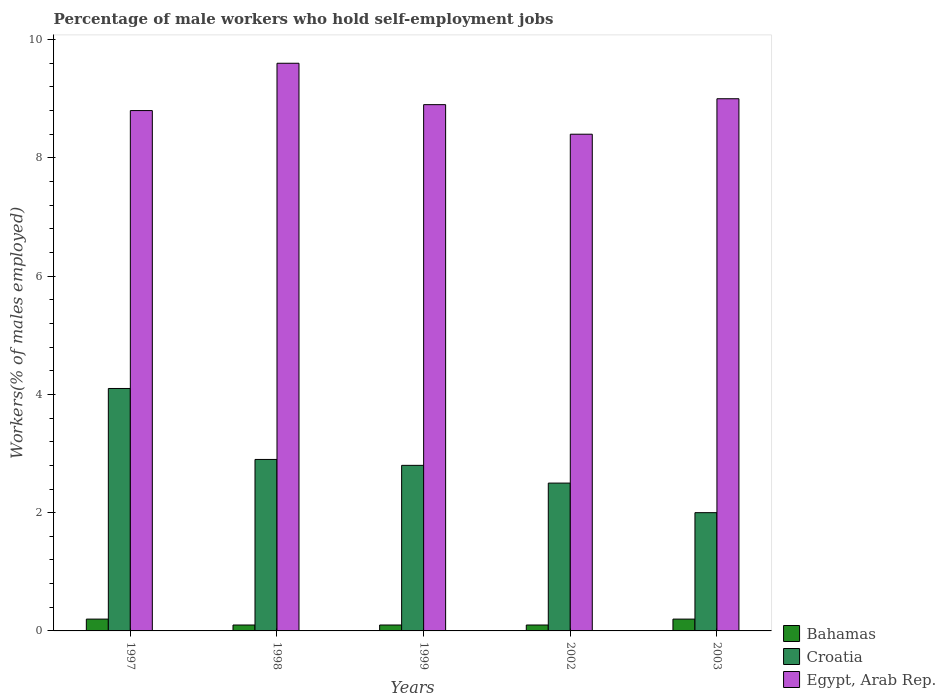How many different coloured bars are there?
Your response must be concise. 3. Are the number of bars on each tick of the X-axis equal?
Your answer should be compact. Yes. How many bars are there on the 1st tick from the right?
Ensure brevity in your answer.  3. What is the label of the 3rd group of bars from the left?
Offer a terse response. 1999. In how many cases, is the number of bars for a given year not equal to the number of legend labels?
Your response must be concise. 0. What is the percentage of self-employed male workers in Egypt, Arab Rep. in 1998?
Make the answer very short. 9.6. Across all years, what is the maximum percentage of self-employed male workers in Egypt, Arab Rep.?
Ensure brevity in your answer.  9.6. Across all years, what is the minimum percentage of self-employed male workers in Bahamas?
Give a very brief answer. 0.1. What is the total percentage of self-employed male workers in Croatia in the graph?
Make the answer very short. 14.3. What is the difference between the percentage of self-employed male workers in Bahamas in 1999 and that in 2003?
Provide a succinct answer. -0.1. What is the difference between the percentage of self-employed male workers in Egypt, Arab Rep. in 2003 and the percentage of self-employed male workers in Croatia in 1999?
Make the answer very short. 6.2. What is the average percentage of self-employed male workers in Bahamas per year?
Your response must be concise. 0.14. In the year 1999, what is the difference between the percentage of self-employed male workers in Bahamas and percentage of self-employed male workers in Croatia?
Your answer should be very brief. -2.7. What is the difference between the highest and the second highest percentage of self-employed male workers in Croatia?
Your answer should be very brief. 1.2. What is the difference between the highest and the lowest percentage of self-employed male workers in Croatia?
Give a very brief answer. 2.1. In how many years, is the percentage of self-employed male workers in Croatia greater than the average percentage of self-employed male workers in Croatia taken over all years?
Offer a terse response. 2. Is the sum of the percentage of self-employed male workers in Bahamas in 1997 and 1999 greater than the maximum percentage of self-employed male workers in Croatia across all years?
Your response must be concise. No. What does the 2nd bar from the left in 1997 represents?
Your answer should be compact. Croatia. What does the 3rd bar from the right in 1999 represents?
Offer a terse response. Bahamas. How many bars are there?
Offer a very short reply. 15. How many years are there in the graph?
Keep it short and to the point. 5. Are the values on the major ticks of Y-axis written in scientific E-notation?
Offer a terse response. No. Does the graph contain any zero values?
Provide a succinct answer. No. How many legend labels are there?
Give a very brief answer. 3. How are the legend labels stacked?
Your answer should be compact. Vertical. What is the title of the graph?
Offer a terse response. Percentage of male workers who hold self-employment jobs. What is the label or title of the X-axis?
Keep it short and to the point. Years. What is the label or title of the Y-axis?
Your answer should be compact. Workers(% of males employed). What is the Workers(% of males employed) in Bahamas in 1997?
Provide a succinct answer. 0.2. What is the Workers(% of males employed) in Croatia in 1997?
Your response must be concise. 4.1. What is the Workers(% of males employed) of Egypt, Arab Rep. in 1997?
Your answer should be compact. 8.8. What is the Workers(% of males employed) in Bahamas in 1998?
Your answer should be very brief. 0.1. What is the Workers(% of males employed) of Croatia in 1998?
Provide a succinct answer. 2.9. What is the Workers(% of males employed) in Egypt, Arab Rep. in 1998?
Provide a succinct answer. 9.6. What is the Workers(% of males employed) of Bahamas in 1999?
Keep it short and to the point. 0.1. What is the Workers(% of males employed) in Croatia in 1999?
Ensure brevity in your answer.  2.8. What is the Workers(% of males employed) of Egypt, Arab Rep. in 1999?
Keep it short and to the point. 8.9. What is the Workers(% of males employed) in Bahamas in 2002?
Provide a succinct answer. 0.1. What is the Workers(% of males employed) of Egypt, Arab Rep. in 2002?
Give a very brief answer. 8.4. What is the Workers(% of males employed) of Bahamas in 2003?
Ensure brevity in your answer.  0.2. What is the Workers(% of males employed) in Croatia in 2003?
Make the answer very short. 2. What is the Workers(% of males employed) in Egypt, Arab Rep. in 2003?
Give a very brief answer. 9. Across all years, what is the maximum Workers(% of males employed) of Bahamas?
Your answer should be compact. 0.2. Across all years, what is the maximum Workers(% of males employed) in Croatia?
Give a very brief answer. 4.1. Across all years, what is the maximum Workers(% of males employed) in Egypt, Arab Rep.?
Ensure brevity in your answer.  9.6. Across all years, what is the minimum Workers(% of males employed) of Bahamas?
Provide a succinct answer. 0.1. Across all years, what is the minimum Workers(% of males employed) in Egypt, Arab Rep.?
Make the answer very short. 8.4. What is the total Workers(% of males employed) in Bahamas in the graph?
Your answer should be very brief. 0.7. What is the total Workers(% of males employed) of Egypt, Arab Rep. in the graph?
Your answer should be very brief. 44.7. What is the difference between the Workers(% of males employed) in Egypt, Arab Rep. in 1997 and that in 1998?
Your response must be concise. -0.8. What is the difference between the Workers(% of males employed) of Bahamas in 1997 and that in 1999?
Your answer should be compact. 0.1. What is the difference between the Workers(% of males employed) of Egypt, Arab Rep. in 1997 and that in 1999?
Provide a succinct answer. -0.1. What is the difference between the Workers(% of males employed) of Bahamas in 1997 and that in 2002?
Your answer should be compact. 0.1. What is the difference between the Workers(% of males employed) of Croatia in 1997 and that in 2002?
Your answer should be compact. 1.6. What is the difference between the Workers(% of males employed) of Croatia in 1997 and that in 2003?
Ensure brevity in your answer.  2.1. What is the difference between the Workers(% of males employed) of Croatia in 1998 and that in 1999?
Your response must be concise. 0.1. What is the difference between the Workers(% of males employed) of Egypt, Arab Rep. in 1998 and that in 1999?
Offer a very short reply. 0.7. What is the difference between the Workers(% of males employed) in Croatia in 1998 and that in 2002?
Ensure brevity in your answer.  0.4. What is the difference between the Workers(% of males employed) in Egypt, Arab Rep. in 1998 and that in 2002?
Your answer should be very brief. 1.2. What is the difference between the Workers(% of males employed) of Croatia in 1998 and that in 2003?
Offer a terse response. 0.9. What is the difference between the Workers(% of males employed) of Egypt, Arab Rep. in 1998 and that in 2003?
Your response must be concise. 0.6. What is the difference between the Workers(% of males employed) in Bahamas in 1999 and that in 2002?
Make the answer very short. 0. What is the difference between the Workers(% of males employed) in Croatia in 1999 and that in 2002?
Make the answer very short. 0.3. What is the difference between the Workers(% of males employed) of Egypt, Arab Rep. in 1999 and that in 2002?
Offer a terse response. 0.5. What is the difference between the Workers(% of males employed) in Bahamas in 1999 and that in 2003?
Provide a short and direct response. -0.1. What is the difference between the Workers(% of males employed) of Egypt, Arab Rep. in 1999 and that in 2003?
Provide a succinct answer. -0.1. What is the difference between the Workers(% of males employed) of Croatia in 2002 and that in 2003?
Give a very brief answer. 0.5. What is the difference between the Workers(% of males employed) of Egypt, Arab Rep. in 2002 and that in 2003?
Ensure brevity in your answer.  -0.6. What is the difference between the Workers(% of males employed) in Bahamas in 1997 and the Workers(% of males employed) in Egypt, Arab Rep. in 1998?
Make the answer very short. -9.4. What is the difference between the Workers(% of males employed) in Croatia in 1997 and the Workers(% of males employed) in Egypt, Arab Rep. in 1998?
Ensure brevity in your answer.  -5.5. What is the difference between the Workers(% of males employed) in Bahamas in 1997 and the Workers(% of males employed) in Croatia in 1999?
Keep it short and to the point. -2.6. What is the difference between the Workers(% of males employed) in Croatia in 1997 and the Workers(% of males employed) in Egypt, Arab Rep. in 1999?
Your answer should be compact. -4.8. What is the difference between the Workers(% of males employed) of Bahamas in 1997 and the Workers(% of males employed) of Croatia in 2002?
Your response must be concise. -2.3. What is the difference between the Workers(% of males employed) in Bahamas in 1997 and the Workers(% of males employed) in Egypt, Arab Rep. in 2003?
Provide a succinct answer. -8.8. What is the difference between the Workers(% of males employed) of Croatia in 1998 and the Workers(% of males employed) of Egypt, Arab Rep. in 1999?
Offer a very short reply. -6. What is the difference between the Workers(% of males employed) in Bahamas in 1998 and the Workers(% of males employed) in Egypt, Arab Rep. in 2002?
Provide a succinct answer. -8.3. What is the difference between the Workers(% of males employed) in Croatia in 1998 and the Workers(% of males employed) in Egypt, Arab Rep. in 2002?
Offer a terse response. -5.5. What is the difference between the Workers(% of males employed) of Bahamas in 1998 and the Workers(% of males employed) of Egypt, Arab Rep. in 2003?
Provide a succinct answer. -8.9. What is the difference between the Workers(% of males employed) of Bahamas in 1999 and the Workers(% of males employed) of Croatia in 2002?
Make the answer very short. -2.4. What is the difference between the Workers(% of males employed) of Croatia in 1999 and the Workers(% of males employed) of Egypt, Arab Rep. in 2002?
Offer a terse response. -5.6. What is the difference between the Workers(% of males employed) of Bahamas in 1999 and the Workers(% of males employed) of Egypt, Arab Rep. in 2003?
Your answer should be compact. -8.9. What is the difference between the Workers(% of males employed) of Croatia in 1999 and the Workers(% of males employed) of Egypt, Arab Rep. in 2003?
Keep it short and to the point. -6.2. What is the difference between the Workers(% of males employed) in Bahamas in 2002 and the Workers(% of males employed) in Egypt, Arab Rep. in 2003?
Provide a short and direct response. -8.9. What is the difference between the Workers(% of males employed) in Croatia in 2002 and the Workers(% of males employed) in Egypt, Arab Rep. in 2003?
Keep it short and to the point. -6.5. What is the average Workers(% of males employed) in Bahamas per year?
Your answer should be very brief. 0.14. What is the average Workers(% of males employed) of Croatia per year?
Make the answer very short. 2.86. What is the average Workers(% of males employed) of Egypt, Arab Rep. per year?
Provide a succinct answer. 8.94. In the year 1997, what is the difference between the Workers(% of males employed) of Bahamas and Workers(% of males employed) of Croatia?
Your answer should be very brief. -3.9. In the year 1997, what is the difference between the Workers(% of males employed) in Bahamas and Workers(% of males employed) in Egypt, Arab Rep.?
Ensure brevity in your answer.  -8.6. In the year 1998, what is the difference between the Workers(% of males employed) in Bahamas and Workers(% of males employed) in Egypt, Arab Rep.?
Your response must be concise. -9.5. In the year 1998, what is the difference between the Workers(% of males employed) of Croatia and Workers(% of males employed) of Egypt, Arab Rep.?
Give a very brief answer. -6.7. In the year 1999, what is the difference between the Workers(% of males employed) of Croatia and Workers(% of males employed) of Egypt, Arab Rep.?
Make the answer very short. -6.1. In the year 2002, what is the difference between the Workers(% of males employed) in Bahamas and Workers(% of males employed) in Egypt, Arab Rep.?
Ensure brevity in your answer.  -8.3. In the year 2002, what is the difference between the Workers(% of males employed) in Croatia and Workers(% of males employed) in Egypt, Arab Rep.?
Provide a short and direct response. -5.9. In the year 2003, what is the difference between the Workers(% of males employed) in Bahamas and Workers(% of males employed) in Egypt, Arab Rep.?
Make the answer very short. -8.8. In the year 2003, what is the difference between the Workers(% of males employed) of Croatia and Workers(% of males employed) of Egypt, Arab Rep.?
Make the answer very short. -7. What is the ratio of the Workers(% of males employed) of Croatia in 1997 to that in 1998?
Your response must be concise. 1.41. What is the ratio of the Workers(% of males employed) in Egypt, Arab Rep. in 1997 to that in 1998?
Keep it short and to the point. 0.92. What is the ratio of the Workers(% of males employed) of Croatia in 1997 to that in 1999?
Offer a very short reply. 1.46. What is the ratio of the Workers(% of males employed) of Bahamas in 1997 to that in 2002?
Give a very brief answer. 2. What is the ratio of the Workers(% of males employed) in Croatia in 1997 to that in 2002?
Offer a very short reply. 1.64. What is the ratio of the Workers(% of males employed) in Egypt, Arab Rep. in 1997 to that in 2002?
Provide a succinct answer. 1.05. What is the ratio of the Workers(% of males employed) in Croatia in 1997 to that in 2003?
Your answer should be very brief. 2.05. What is the ratio of the Workers(% of males employed) of Egypt, Arab Rep. in 1997 to that in 2003?
Your answer should be very brief. 0.98. What is the ratio of the Workers(% of males employed) of Croatia in 1998 to that in 1999?
Your response must be concise. 1.04. What is the ratio of the Workers(% of males employed) of Egypt, Arab Rep. in 1998 to that in 1999?
Provide a short and direct response. 1.08. What is the ratio of the Workers(% of males employed) of Croatia in 1998 to that in 2002?
Provide a succinct answer. 1.16. What is the ratio of the Workers(% of males employed) of Egypt, Arab Rep. in 1998 to that in 2002?
Make the answer very short. 1.14. What is the ratio of the Workers(% of males employed) in Bahamas in 1998 to that in 2003?
Your answer should be compact. 0.5. What is the ratio of the Workers(% of males employed) in Croatia in 1998 to that in 2003?
Offer a terse response. 1.45. What is the ratio of the Workers(% of males employed) of Egypt, Arab Rep. in 1998 to that in 2003?
Keep it short and to the point. 1.07. What is the ratio of the Workers(% of males employed) in Croatia in 1999 to that in 2002?
Your response must be concise. 1.12. What is the ratio of the Workers(% of males employed) of Egypt, Arab Rep. in 1999 to that in 2002?
Your answer should be compact. 1.06. What is the ratio of the Workers(% of males employed) in Croatia in 1999 to that in 2003?
Provide a succinct answer. 1.4. What is the ratio of the Workers(% of males employed) of Egypt, Arab Rep. in 1999 to that in 2003?
Provide a short and direct response. 0.99. What is the ratio of the Workers(% of males employed) of Croatia in 2002 to that in 2003?
Ensure brevity in your answer.  1.25. What is the difference between the highest and the second highest Workers(% of males employed) in Bahamas?
Ensure brevity in your answer.  0. What is the difference between the highest and the second highest Workers(% of males employed) in Croatia?
Ensure brevity in your answer.  1.2. What is the difference between the highest and the lowest Workers(% of males employed) of Croatia?
Give a very brief answer. 2.1. 